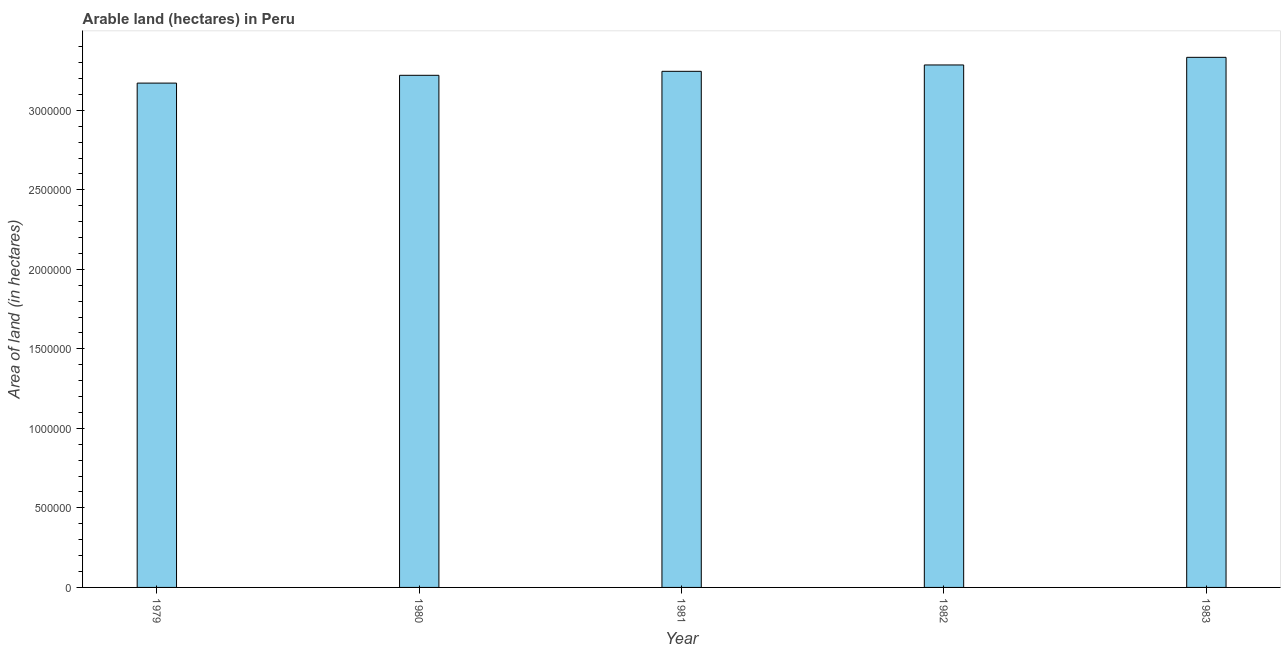Does the graph contain any zero values?
Make the answer very short. No. Does the graph contain grids?
Your answer should be compact. No. What is the title of the graph?
Ensure brevity in your answer.  Arable land (hectares) in Peru. What is the label or title of the Y-axis?
Offer a terse response. Area of land (in hectares). What is the area of land in 1981?
Give a very brief answer. 3.24e+06. Across all years, what is the maximum area of land?
Your answer should be compact. 3.33e+06. Across all years, what is the minimum area of land?
Offer a very short reply. 3.17e+06. In which year was the area of land maximum?
Offer a terse response. 1983. In which year was the area of land minimum?
Offer a terse response. 1979. What is the sum of the area of land?
Your response must be concise. 1.63e+07. What is the difference between the area of land in 1982 and 1983?
Make the answer very short. -4.80e+04. What is the average area of land per year?
Offer a very short reply. 3.25e+06. What is the median area of land?
Ensure brevity in your answer.  3.24e+06. In how many years, is the area of land greater than 1200000 hectares?
Make the answer very short. 5. Is the area of land in 1980 less than that in 1981?
Give a very brief answer. Yes. Is the difference between the area of land in 1981 and 1982 greater than the difference between any two years?
Provide a short and direct response. No. What is the difference between the highest and the second highest area of land?
Your answer should be compact. 4.80e+04. Is the sum of the area of land in 1981 and 1983 greater than the maximum area of land across all years?
Ensure brevity in your answer.  Yes. What is the difference between the highest and the lowest area of land?
Your answer should be compact. 1.62e+05. How many bars are there?
Offer a terse response. 5. Are all the bars in the graph horizontal?
Make the answer very short. No. How many years are there in the graph?
Keep it short and to the point. 5. What is the difference between two consecutive major ticks on the Y-axis?
Provide a succinct answer. 5.00e+05. What is the Area of land (in hectares) of 1979?
Provide a short and direct response. 3.17e+06. What is the Area of land (in hectares) of 1980?
Make the answer very short. 3.22e+06. What is the Area of land (in hectares) of 1981?
Your response must be concise. 3.24e+06. What is the Area of land (in hectares) of 1982?
Your answer should be compact. 3.28e+06. What is the Area of land (in hectares) of 1983?
Your answer should be very brief. 3.33e+06. What is the difference between the Area of land (in hectares) in 1979 and 1980?
Your answer should be compact. -4.90e+04. What is the difference between the Area of land (in hectares) in 1979 and 1981?
Give a very brief answer. -7.40e+04. What is the difference between the Area of land (in hectares) in 1979 and 1982?
Offer a terse response. -1.14e+05. What is the difference between the Area of land (in hectares) in 1979 and 1983?
Make the answer very short. -1.62e+05. What is the difference between the Area of land (in hectares) in 1980 and 1981?
Make the answer very short. -2.50e+04. What is the difference between the Area of land (in hectares) in 1980 and 1982?
Offer a very short reply. -6.50e+04. What is the difference between the Area of land (in hectares) in 1980 and 1983?
Your response must be concise. -1.13e+05. What is the difference between the Area of land (in hectares) in 1981 and 1983?
Your answer should be compact. -8.80e+04. What is the difference between the Area of land (in hectares) in 1982 and 1983?
Offer a terse response. -4.80e+04. What is the ratio of the Area of land (in hectares) in 1979 to that in 1981?
Your response must be concise. 0.98. What is the ratio of the Area of land (in hectares) in 1979 to that in 1983?
Give a very brief answer. 0.95. What is the ratio of the Area of land (in hectares) in 1980 to that in 1982?
Ensure brevity in your answer.  0.98. What is the ratio of the Area of land (in hectares) in 1981 to that in 1982?
Provide a succinct answer. 0.99. What is the ratio of the Area of land (in hectares) in 1982 to that in 1983?
Provide a short and direct response. 0.99. 